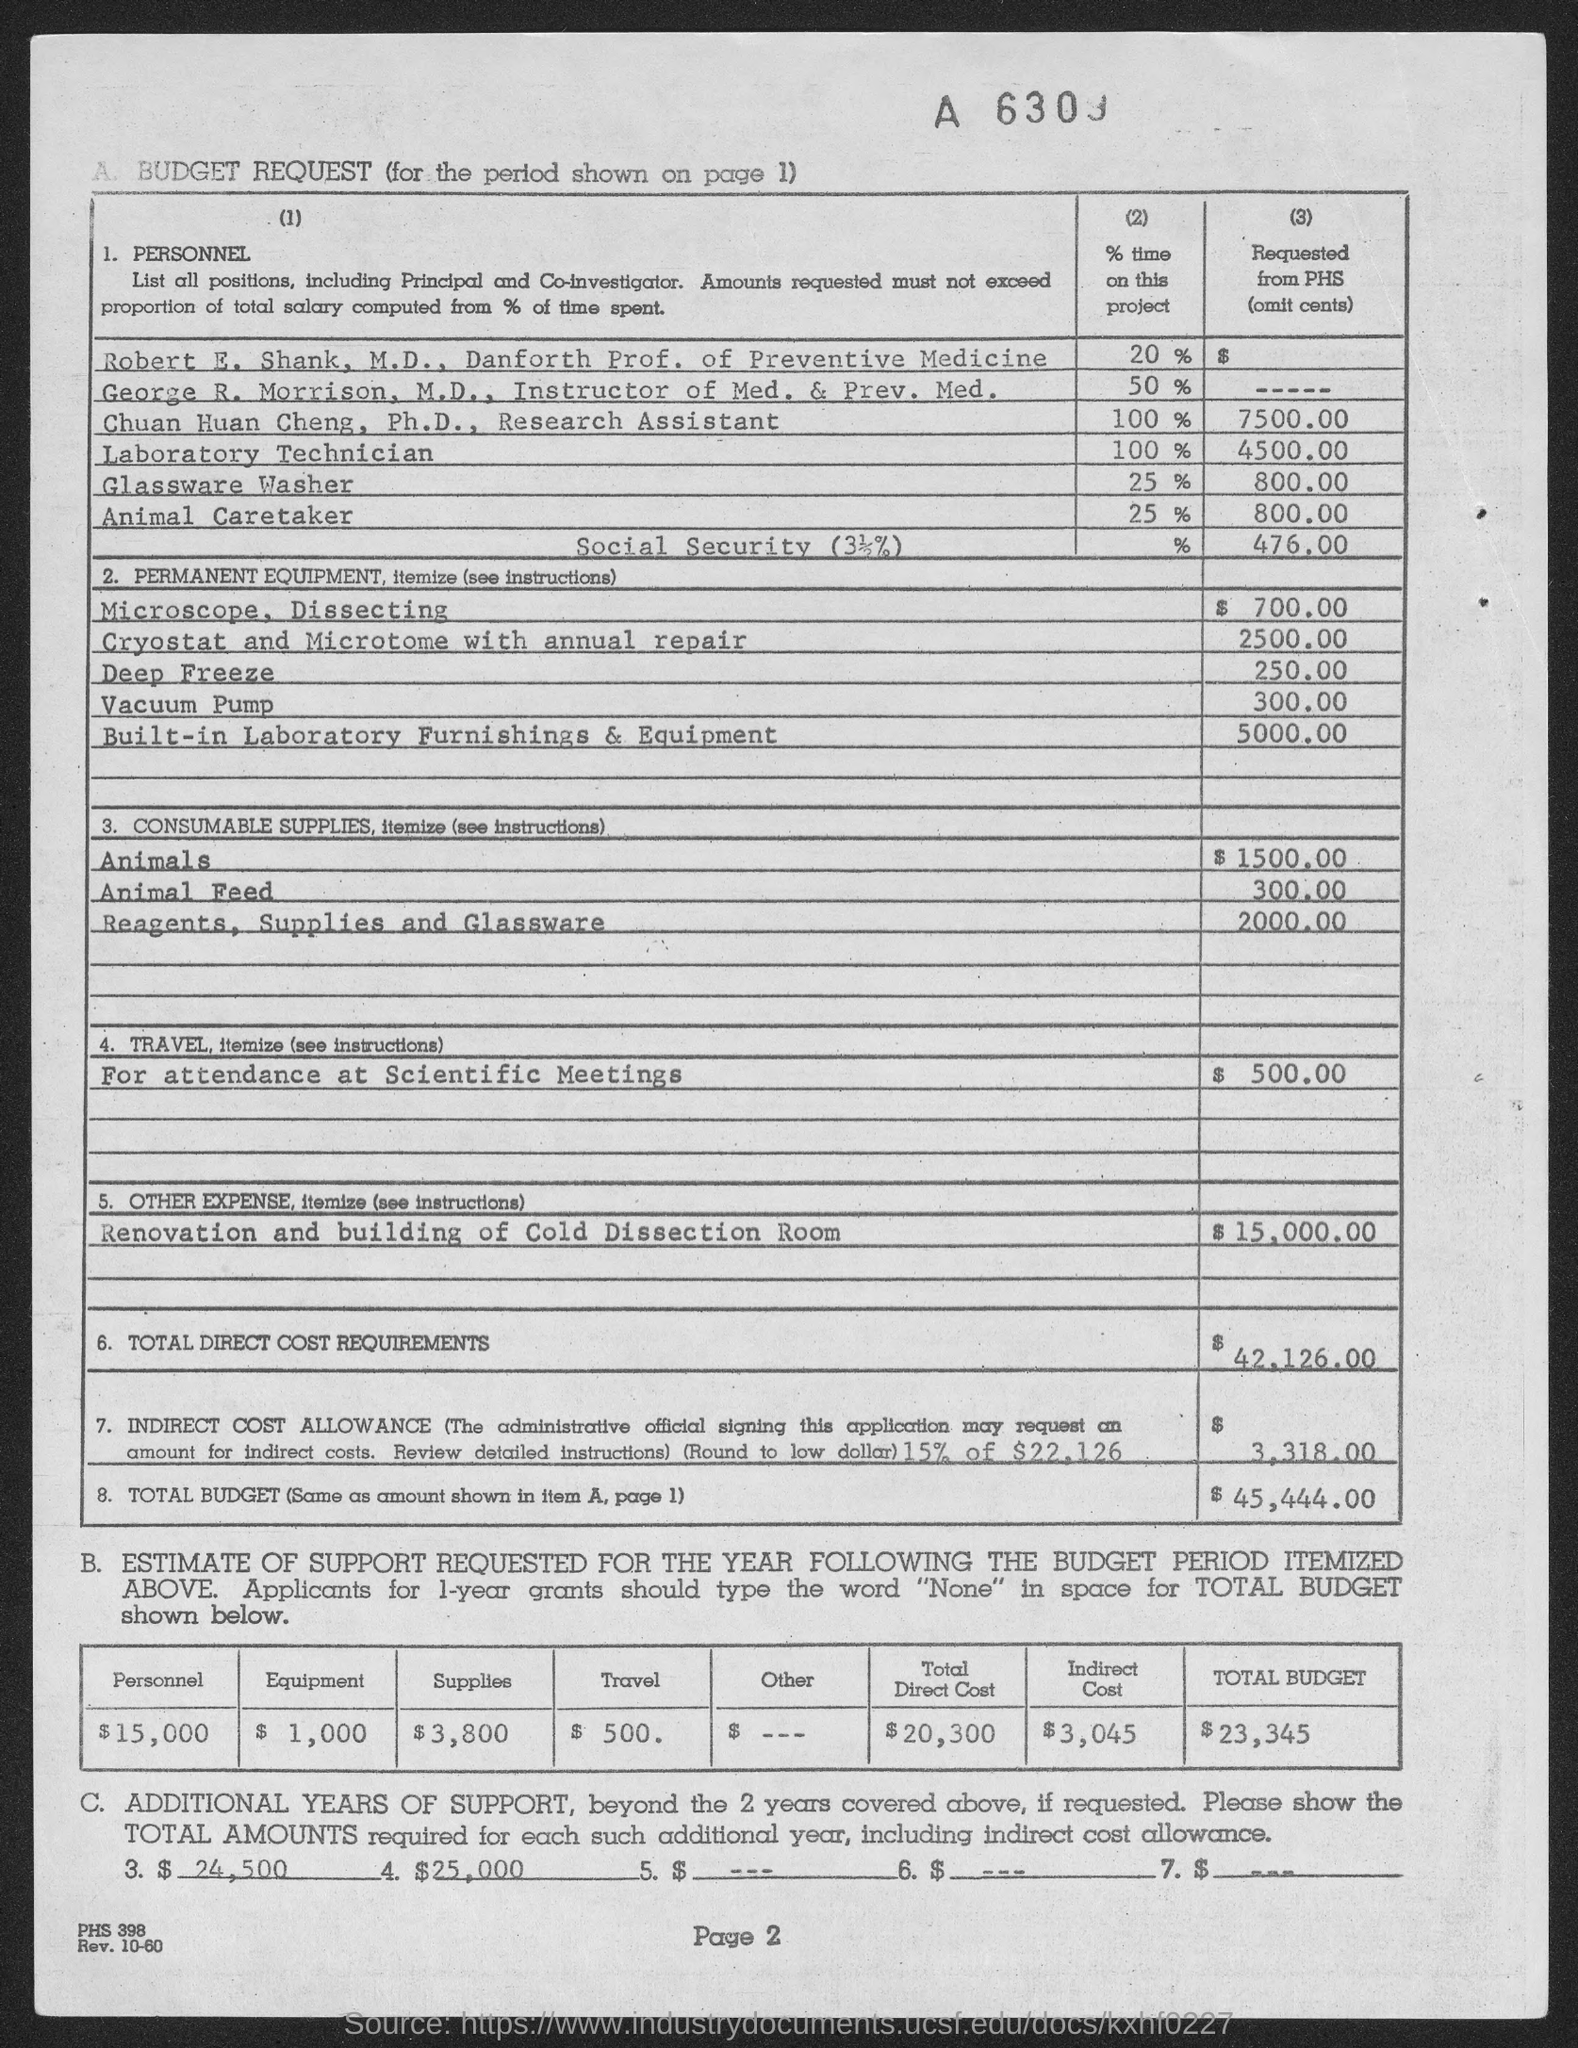Draw attention to some important aspects in this diagram. Chuan Huan Cheng, Ph.D., is currently a research assistant. Robert E. Shank is the Danforth Professor of Preventive Medicine. George R. Morrison, M.D. holds the position of Instructor of Medicine and Preventive Medicine. 